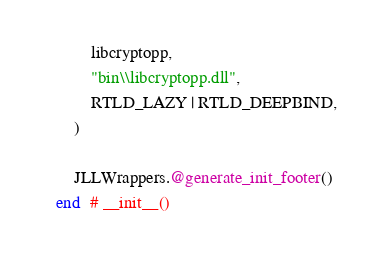Convert code to text. <code><loc_0><loc_0><loc_500><loc_500><_Julia_>        libcryptopp,
        "bin\\libcryptopp.dll",
        RTLD_LAZY | RTLD_DEEPBIND,
    )

    JLLWrappers.@generate_init_footer()
end  # __init__()
</code> 